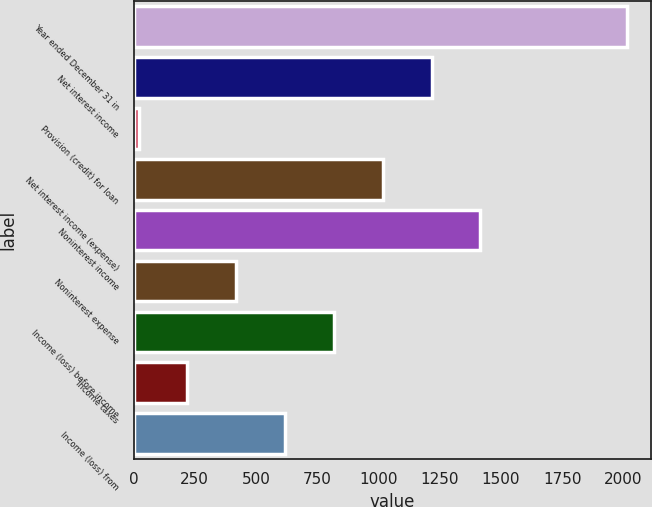Convert chart. <chart><loc_0><loc_0><loc_500><loc_500><bar_chart><fcel>Year ended December 31 in<fcel>Net interest income<fcel>Provision (credit) for loan<fcel>Net interest income (expense)<fcel>Noninterest income<fcel>Noninterest expense<fcel>Income (loss) before income<fcel>Income taxes<fcel>Income (loss) from<nl><fcel>2014<fcel>1216.8<fcel>21<fcel>1017.5<fcel>1416.1<fcel>419.6<fcel>818.2<fcel>220.3<fcel>618.9<nl></chart> 